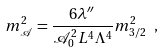Convert formula to latex. <formula><loc_0><loc_0><loc_500><loc_500>m ^ { 2 } _ { \mathcal { A } } = \frac { 6 \lambda ^ { \prime \prime } } { \mathcal { A } _ { 0 } ^ { 2 } L ^ { 4 } \Lambda ^ { 4 } } m _ { 3 / 2 } ^ { 2 } \ ,</formula> 